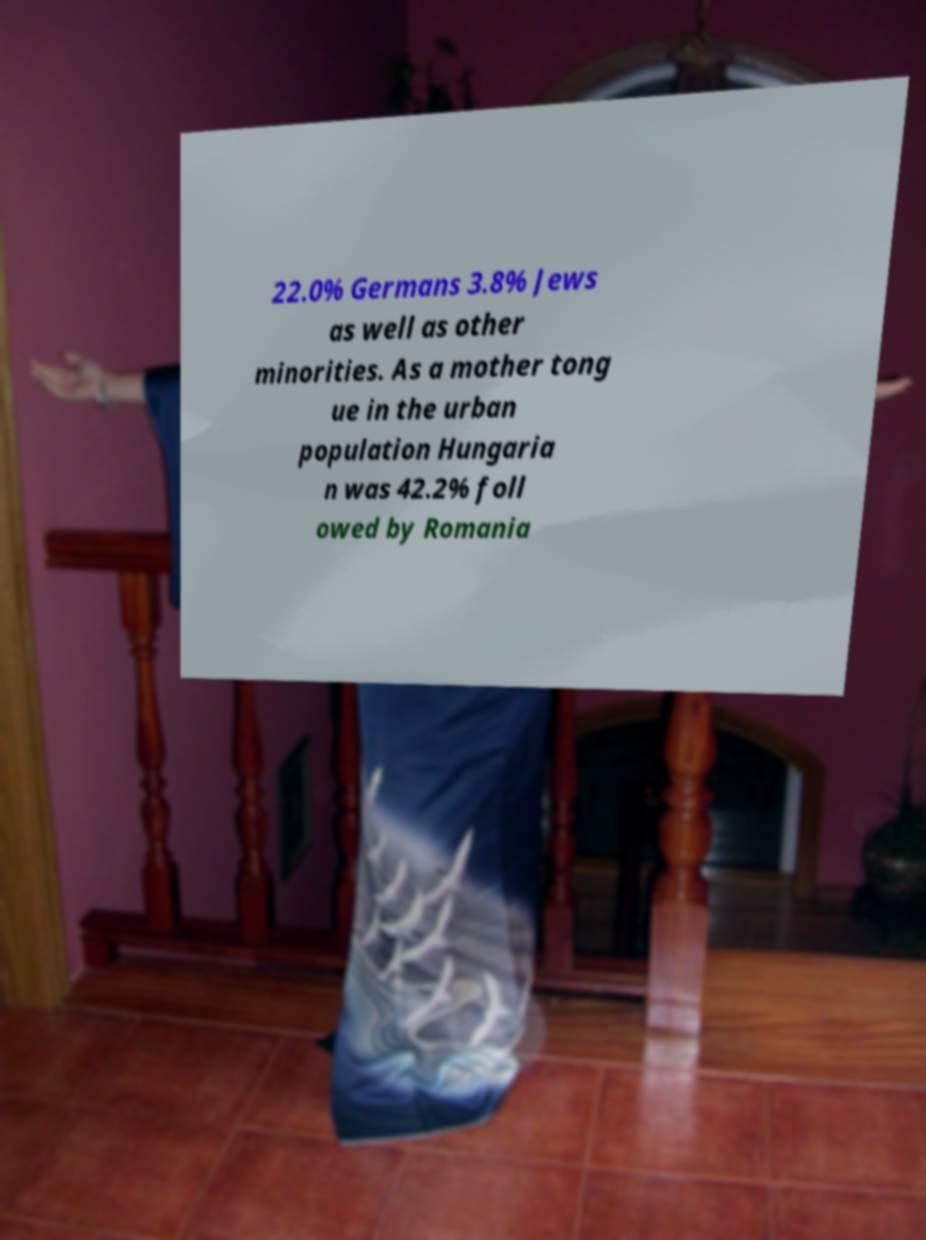Can you accurately transcribe the text from the provided image for me? 22.0% Germans 3.8% Jews as well as other minorities. As a mother tong ue in the urban population Hungaria n was 42.2% foll owed by Romania 